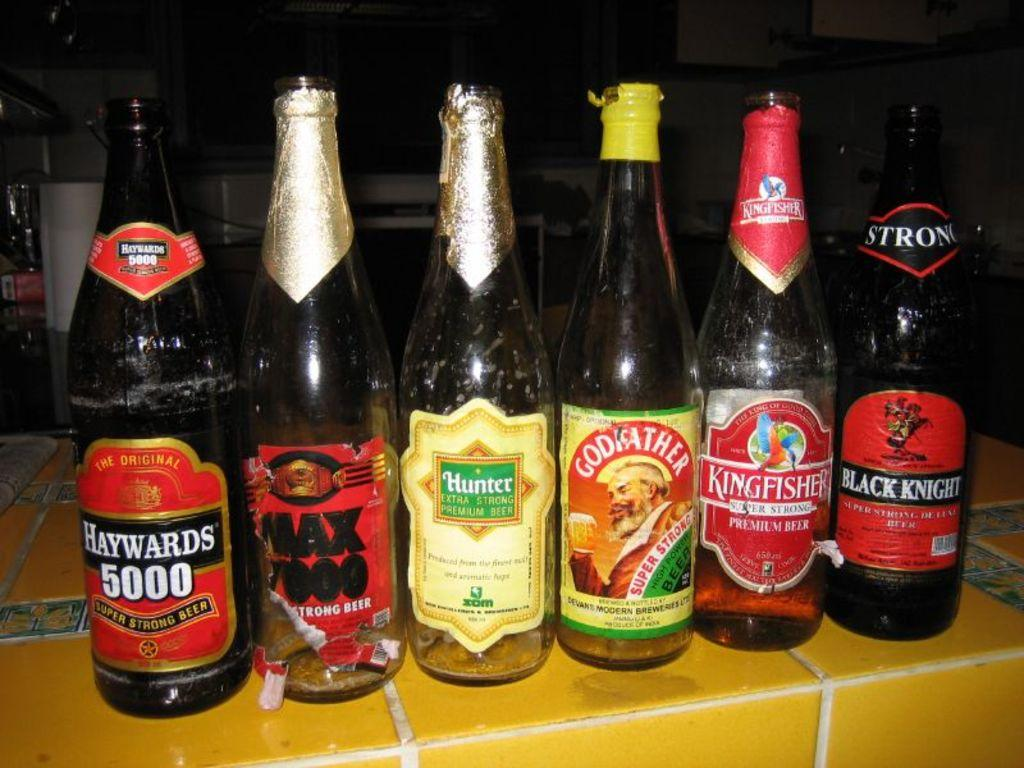<image>
Give a short and clear explanation of the subsequent image. A bottle of haywards 5000 sits next to a clear bottle 